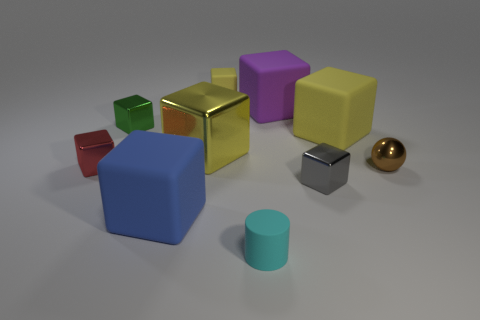How many yellow cubes must be subtracted to get 1 yellow cubes? 2 Subtract all cylinders. How many objects are left? 9 Subtract 1 spheres. How many spheres are left? 0 Subtract all yellow blocks. Subtract all green cylinders. How many blocks are left? 5 Subtract all red blocks. How many gray balls are left? 0 Subtract all tiny cyan things. Subtract all big metal cubes. How many objects are left? 8 Add 3 purple rubber things. How many purple rubber things are left? 4 Add 4 red metal blocks. How many red metal blocks exist? 5 Subtract all green cubes. How many cubes are left? 7 Subtract all small gray metal cubes. How many cubes are left? 7 